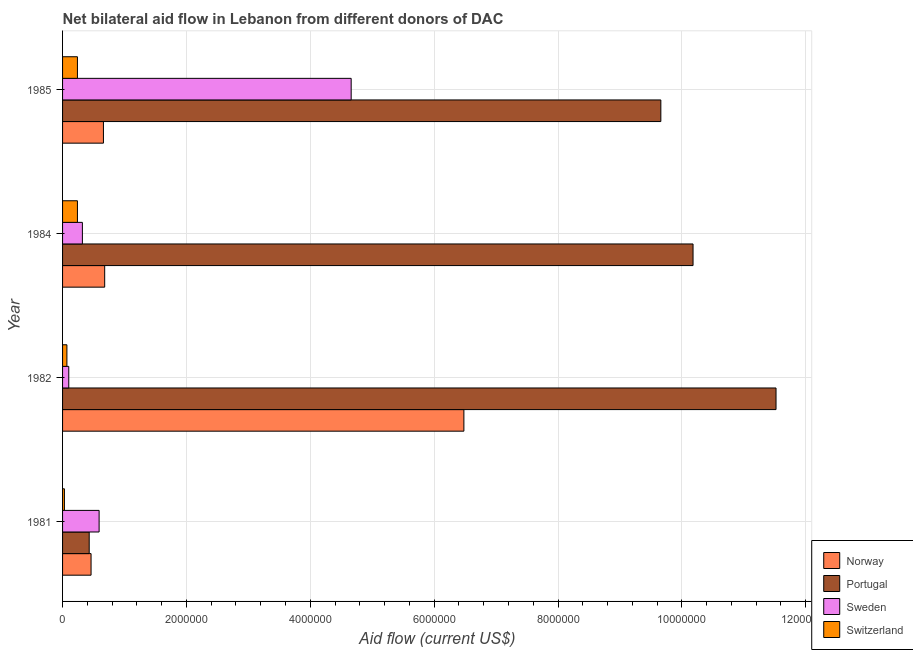How many different coloured bars are there?
Make the answer very short. 4. How many groups of bars are there?
Keep it short and to the point. 4. How many bars are there on the 4th tick from the top?
Your answer should be very brief. 4. How many bars are there on the 3rd tick from the bottom?
Make the answer very short. 4. What is the amount of aid given by sweden in 1985?
Ensure brevity in your answer.  4.66e+06. Across all years, what is the maximum amount of aid given by portugal?
Offer a terse response. 1.15e+07. Across all years, what is the minimum amount of aid given by sweden?
Ensure brevity in your answer.  1.00e+05. In which year was the amount of aid given by sweden maximum?
Provide a succinct answer. 1985. What is the total amount of aid given by norway in the graph?
Make the answer very short. 8.28e+06. What is the difference between the amount of aid given by norway in 1982 and that in 1985?
Give a very brief answer. 5.82e+06. What is the difference between the amount of aid given by sweden in 1981 and the amount of aid given by portugal in 1985?
Make the answer very short. -9.07e+06. What is the average amount of aid given by portugal per year?
Offer a terse response. 7.95e+06. In the year 1984, what is the difference between the amount of aid given by sweden and amount of aid given by switzerland?
Ensure brevity in your answer.  8.00e+04. What is the ratio of the amount of aid given by portugal in 1984 to that in 1985?
Offer a very short reply. 1.05. What is the difference between the highest and the second highest amount of aid given by portugal?
Keep it short and to the point. 1.34e+06. What is the difference between the highest and the lowest amount of aid given by norway?
Offer a very short reply. 6.02e+06. What does the 3rd bar from the top in 1984 represents?
Offer a terse response. Portugal. What does the 4th bar from the bottom in 1985 represents?
Your answer should be very brief. Switzerland. What is the difference between two consecutive major ticks on the X-axis?
Provide a short and direct response. 2.00e+06. Are the values on the major ticks of X-axis written in scientific E-notation?
Offer a terse response. No. What is the title of the graph?
Give a very brief answer. Net bilateral aid flow in Lebanon from different donors of DAC. Does "Primary education" appear as one of the legend labels in the graph?
Offer a terse response. No. What is the label or title of the X-axis?
Keep it short and to the point. Aid flow (current US$). What is the label or title of the Y-axis?
Provide a succinct answer. Year. What is the Aid flow (current US$) of Sweden in 1981?
Offer a terse response. 5.90e+05. What is the Aid flow (current US$) of Switzerland in 1981?
Provide a succinct answer. 3.00e+04. What is the Aid flow (current US$) of Norway in 1982?
Offer a terse response. 6.48e+06. What is the Aid flow (current US$) of Portugal in 1982?
Offer a very short reply. 1.15e+07. What is the Aid flow (current US$) of Norway in 1984?
Provide a succinct answer. 6.80e+05. What is the Aid flow (current US$) in Portugal in 1984?
Provide a short and direct response. 1.02e+07. What is the Aid flow (current US$) of Switzerland in 1984?
Your response must be concise. 2.40e+05. What is the Aid flow (current US$) in Portugal in 1985?
Provide a succinct answer. 9.66e+06. What is the Aid flow (current US$) in Sweden in 1985?
Your answer should be very brief. 4.66e+06. What is the Aid flow (current US$) of Switzerland in 1985?
Your response must be concise. 2.40e+05. Across all years, what is the maximum Aid flow (current US$) of Norway?
Your answer should be compact. 6.48e+06. Across all years, what is the maximum Aid flow (current US$) of Portugal?
Give a very brief answer. 1.15e+07. Across all years, what is the maximum Aid flow (current US$) of Sweden?
Provide a succinct answer. 4.66e+06. Across all years, what is the maximum Aid flow (current US$) in Switzerland?
Your answer should be compact. 2.40e+05. Across all years, what is the minimum Aid flow (current US$) in Sweden?
Offer a very short reply. 1.00e+05. What is the total Aid flow (current US$) of Norway in the graph?
Your answer should be very brief. 8.28e+06. What is the total Aid flow (current US$) of Portugal in the graph?
Give a very brief answer. 3.18e+07. What is the total Aid flow (current US$) of Sweden in the graph?
Ensure brevity in your answer.  5.67e+06. What is the total Aid flow (current US$) in Switzerland in the graph?
Your answer should be compact. 5.80e+05. What is the difference between the Aid flow (current US$) in Norway in 1981 and that in 1982?
Your answer should be very brief. -6.02e+06. What is the difference between the Aid flow (current US$) in Portugal in 1981 and that in 1982?
Provide a succinct answer. -1.11e+07. What is the difference between the Aid flow (current US$) of Sweden in 1981 and that in 1982?
Your answer should be very brief. 4.90e+05. What is the difference between the Aid flow (current US$) in Switzerland in 1981 and that in 1982?
Make the answer very short. -4.00e+04. What is the difference between the Aid flow (current US$) of Norway in 1981 and that in 1984?
Offer a terse response. -2.20e+05. What is the difference between the Aid flow (current US$) of Portugal in 1981 and that in 1984?
Make the answer very short. -9.75e+06. What is the difference between the Aid flow (current US$) of Sweden in 1981 and that in 1984?
Offer a terse response. 2.70e+05. What is the difference between the Aid flow (current US$) of Switzerland in 1981 and that in 1984?
Your answer should be compact. -2.10e+05. What is the difference between the Aid flow (current US$) of Portugal in 1981 and that in 1985?
Offer a very short reply. -9.23e+06. What is the difference between the Aid flow (current US$) in Sweden in 1981 and that in 1985?
Provide a short and direct response. -4.07e+06. What is the difference between the Aid flow (current US$) in Switzerland in 1981 and that in 1985?
Give a very brief answer. -2.10e+05. What is the difference between the Aid flow (current US$) of Norway in 1982 and that in 1984?
Your response must be concise. 5.80e+06. What is the difference between the Aid flow (current US$) in Portugal in 1982 and that in 1984?
Your response must be concise. 1.34e+06. What is the difference between the Aid flow (current US$) in Switzerland in 1982 and that in 1984?
Provide a succinct answer. -1.70e+05. What is the difference between the Aid flow (current US$) in Norway in 1982 and that in 1985?
Give a very brief answer. 5.82e+06. What is the difference between the Aid flow (current US$) in Portugal in 1982 and that in 1985?
Make the answer very short. 1.86e+06. What is the difference between the Aid flow (current US$) of Sweden in 1982 and that in 1985?
Provide a succinct answer. -4.56e+06. What is the difference between the Aid flow (current US$) in Switzerland in 1982 and that in 1985?
Your answer should be very brief. -1.70e+05. What is the difference between the Aid flow (current US$) in Portugal in 1984 and that in 1985?
Your answer should be very brief. 5.20e+05. What is the difference between the Aid flow (current US$) of Sweden in 1984 and that in 1985?
Provide a succinct answer. -4.34e+06. What is the difference between the Aid flow (current US$) in Norway in 1981 and the Aid flow (current US$) in Portugal in 1982?
Your answer should be compact. -1.11e+07. What is the difference between the Aid flow (current US$) of Norway in 1981 and the Aid flow (current US$) of Sweden in 1982?
Your answer should be compact. 3.60e+05. What is the difference between the Aid flow (current US$) in Norway in 1981 and the Aid flow (current US$) in Switzerland in 1982?
Offer a terse response. 3.90e+05. What is the difference between the Aid flow (current US$) of Portugal in 1981 and the Aid flow (current US$) of Sweden in 1982?
Offer a terse response. 3.30e+05. What is the difference between the Aid flow (current US$) of Portugal in 1981 and the Aid flow (current US$) of Switzerland in 1982?
Keep it short and to the point. 3.60e+05. What is the difference between the Aid flow (current US$) in Sweden in 1981 and the Aid flow (current US$) in Switzerland in 1982?
Offer a terse response. 5.20e+05. What is the difference between the Aid flow (current US$) in Norway in 1981 and the Aid flow (current US$) in Portugal in 1984?
Your response must be concise. -9.72e+06. What is the difference between the Aid flow (current US$) in Norway in 1981 and the Aid flow (current US$) in Sweden in 1984?
Your response must be concise. 1.40e+05. What is the difference between the Aid flow (current US$) in Portugal in 1981 and the Aid flow (current US$) in Switzerland in 1984?
Keep it short and to the point. 1.90e+05. What is the difference between the Aid flow (current US$) in Norway in 1981 and the Aid flow (current US$) in Portugal in 1985?
Offer a very short reply. -9.20e+06. What is the difference between the Aid flow (current US$) in Norway in 1981 and the Aid flow (current US$) in Sweden in 1985?
Your answer should be compact. -4.20e+06. What is the difference between the Aid flow (current US$) of Norway in 1981 and the Aid flow (current US$) of Switzerland in 1985?
Keep it short and to the point. 2.20e+05. What is the difference between the Aid flow (current US$) in Portugal in 1981 and the Aid flow (current US$) in Sweden in 1985?
Provide a short and direct response. -4.23e+06. What is the difference between the Aid flow (current US$) of Norway in 1982 and the Aid flow (current US$) of Portugal in 1984?
Your answer should be very brief. -3.70e+06. What is the difference between the Aid flow (current US$) of Norway in 1982 and the Aid flow (current US$) of Sweden in 1984?
Provide a short and direct response. 6.16e+06. What is the difference between the Aid flow (current US$) in Norway in 1982 and the Aid flow (current US$) in Switzerland in 1984?
Make the answer very short. 6.24e+06. What is the difference between the Aid flow (current US$) of Portugal in 1982 and the Aid flow (current US$) of Sweden in 1984?
Give a very brief answer. 1.12e+07. What is the difference between the Aid flow (current US$) in Portugal in 1982 and the Aid flow (current US$) in Switzerland in 1984?
Provide a short and direct response. 1.13e+07. What is the difference between the Aid flow (current US$) in Norway in 1982 and the Aid flow (current US$) in Portugal in 1985?
Your answer should be compact. -3.18e+06. What is the difference between the Aid flow (current US$) of Norway in 1982 and the Aid flow (current US$) of Sweden in 1985?
Your answer should be compact. 1.82e+06. What is the difference between the Aid flow (current US$) of Norway in 1982 and the Aid flow (current US$) of Switzerland in 1985?
Your answer should be compact. 6.24e+06. What is the difference between the Aid flow (current US$) of Portugal in 1982 and the Aid flow (current US$) of Sweden in 1985?
Provide a short and direct response. 6.86e+06. What is the difference between the Aid flow (current US$) in Portugal in 1982 and the Aid flow (current US$) in Switzerland in 1985?
Your answer should be compact. 1.13e+07. What is the difference between the Aid flow (current US$) of Norway in 1984 and the Aid flow (current US$) of Portugal in 1985?
Make the answer very short. -8.98e+06. What is the difference between the Aid flow (current US$) of Norway in 1984 and the Aid flow (current US$) of Sweden in 1985?
Offer a terse response. -3.98e+06. What is the difference between the Aid flow (current US$) of Norway in 1984 and the Aid flow (current US$) of Switzerland in 1985?
Provide a succinct answer. 4.40e+05. What is the difference between the Aid flow (current US$) in Portugal in 1984 and the Aid flow (current US$) in Sweden in 1985?
Provide a short and direct response. 5.52e+06. What is the difference between the Aid flow (current US$) in Portugal in 1984 and the Aid flow (current US$) in Switzerland in 1985?
Offer a terse response. 9.94e+06. What is the average Aid flow (current US$) of Norway per year?
Offer a terse response. 2.07e+06. What is the average Aid flow (current US$) in Portugal per year?
Your answer should be very brief. 7.95e+06. What is the average Aid flow (current US$) of Sweden per year?
Offer a very short reply. 1.42e+06. What is the average Aid flow (current US$) in Switzerland per year?
Your answer should be compact. 1.45e+05. In the year 1981, what is the difference between the Aid flow (current US$) in Norway and Aid flow (current US$) in Sweden?
Your answer should be very brief. -1.30e+05. In the year 1981, what is the difference between the Aid flow (current US$) in Portugal and Aid flow (current US$) in Switzerland?
Your response must be concise. 4.00e+05. In the year 1981, what is the difference between the Aid flow (current US$) of Sweden and Aid flow (current US$) of Switzerland?
Ensure brevity in your answer.  5.60e+05. In the year 1982, what is the difference between the Aid flow (current US$) in Norway and Aid flow (current US$) in Portugal?
Offer a very short reply. -5.04e+06. In the year 1982, what is the difference between the Aid flow (current US$) in Norway and Aid flow (current US$) in Sweden?
Your answer should be very brief. 6.38e+06. In the year 1982, what is the difference between the Aid flow (current US$) in Norway and Aid flow (current US$) in Switzerland?
Your response must be concise. 6.41e+06. In the year 1982, what is the difference between the Aid flow (current US$) of Portugal and Aid flow (current US$) of Sweden?
Make the answer very short. 1.14e+07. In the year 1982, what is the difference between the Aid flow (current US$) of Portugal and Aid flow (current US$) of Switzerland?
Keep it short and to the point. 1.14e+07. In the year 1982, what is the difference between the Aid flow (current US$) in Sweden and Aid flow (current US$) in Switzerland?
Your response must be concise. 3.00e+04. In the year 1984, what is the difference between the Aid flow (current US$) in Norway and Aid flow (current US$) in Portugal?
Offer a terse response. -9.50e+06. In the year 1984, what is the difference between the Aid flow (current US$) of Portugal and Aid flow (current US$) of Sweden?
Provide a succinct answer. 9.86e+06. In the year 1984, what is the difference between the Aid flow (current US$) of Portugal and Aid flow (current US$) of Switzerland?
Keep it short and to the point. 9.94e+06. In the year 1984, what is the difference between the Aid flow (current US$) of Sweden and Aid flow (current US$) of Switzerland?
Give a very brief answer. 8.00e+04. In the year 1985, what is the difference between the Aid flow (current US$) of Norway and Aid flow (current US$) of Portugal?
Ensure brevity in your answer.  -9.00e+06. In the year 1985, what is the difference between the Aid flow (current US$) of Norway and Aid flow (current US$) of Sweden?
Offer a terse response. -4.00e+06. In the year 1985, what is the difference between the Aid flow (current US$) of Norway and Aid flow (current US$) of Switzerland?
Offer a terse response. 4.20e+05. In the year 1985, what is the difference between the Aid flow (current US$) of Portugal and Aid flow (current US$) of Switzerland?
Give a very brief answer. 9.42e+06. In the year 1985, what is the difference between the Aid flow (current US$) of Sweden and Aid flow (current US$) of Switzerland?
Offer a very short reply. 4.42e+06. What is the ratio of the Aid flow (current US$) of Norway in 1981 to that in 1982?
Offer a very short reply. 0.07. What is the ratio of the Aid flow (current US$) of Portugal in 1981 to that in 1982?
Offer a terse response. 0.04. What is the ratio of the Aid flow (current US$) of Switzerland in 1981 to that in 1982?
Provide a succinct answer. 0.43. What is the ratio of the Aid flow (current US$) in Norway in 1981 to that in 1984?
Offer a terse response. 0.68. What is the ratio of the Aid flow (current US$) of Portugal in 1981 to that in 1984?
Your answer should be very brief. 0.04. What is the ratio of the Aid flow (current US$) of Sweden in 1981 to that in 1984?
Provide a succinct answer. 1.84. What is the ratio of the Aid flow (current US$) of Switzerland in 1981 to that in 1984?
Your answer should be compact. 0.12. What is the ratio of the Aid flow (current US$) in Norway in 1981 to that in 1985?
Offer a very short reply. 0.7. What is the ratio of the Aid flow (current US$) of Portugal in 1981 to that in 1985?
Keep it short and to the point. 0.04. What is the ratio of the Aid flow (current US$) of Sweden in 1981 to that in 1985?
Ensure brevity in your answer.  0.13. What is the ratio of the Aid flow (current US$) of Norway in 1982 to that in 1984?
Provide a succinct answer. 9.53. What is the ratio of the Aid flow (current US$) of Portugal in 1982 to that in 1984?
Provide a short and direct response. 1.13. What is the ratio of the Aid flow (current US$) of Sweden in 1982 to that in 1984?
Your answer should be compact. 0.31. What is the ratio of the Aid flow (current US$) of Switzerland in 1982 to that in 1984?
Give a very brief answer. 0.29. What is the ratio of the Aid flow (current US$) of Norway in 1982 to that in 1985?
Provide a succinct answer. 9.82. What is the ratio of the Aid flow (current US$) of Portugal in 1982 to that in 1985?
Provide a short and direct response. 1.19. What is the ratio of the Aid flow (current US$) in Sweden in 1982 to that in 1985?
Offer a very short reply. 0.02. What is the ratio of the Aid flow (current US$) in Switzerland in 1982 to that in 1985?
Offer a terse response. 0.29. What is the ratio of the Aid flow (current US$) of Norway in 1984 to that in 1985?
Provide a succinct answer. 1.03. What is the ratio of the Aid flow (current US$) of Portugal in 1984 to that in 1985?
Offer a terse response. 1.05. What is the ratio of the Aid flow (current US$) of Sweden in 1984 to that in 1985?
Offer a very short reply. 0.07. What is the difference between the highest and the second highest Aid flow (current US$) of Norway?
Offer a very short reply. 5.80e+06. What is the difference between the highest and the second highest Aid flow (current US$) in Portugal?
Make the answer very short. 1.34e+06. What is the difference between the highest and the second highest Aid flow (current US$) of Sweden?
Provide a succinct answer. 4.07e+06. What is the difference between the highest and the lowest Aid flow (current US$) of Norway?
Offer a very short reply. 6.02e+06. What is the difference between the highest and the lowest Aid flow (current US$) of Portugal?
Your response must be concise. 1.11e+07. What is the difference between the highest and the lowest Aid flow (current US$) in Sweden?
Your answer should be very brief. 4.56e+06. What is the difference between the highest and the lowest Aid flow (current US$) in Switzerland?
Provide a succinct answer. 2.10e+05. 